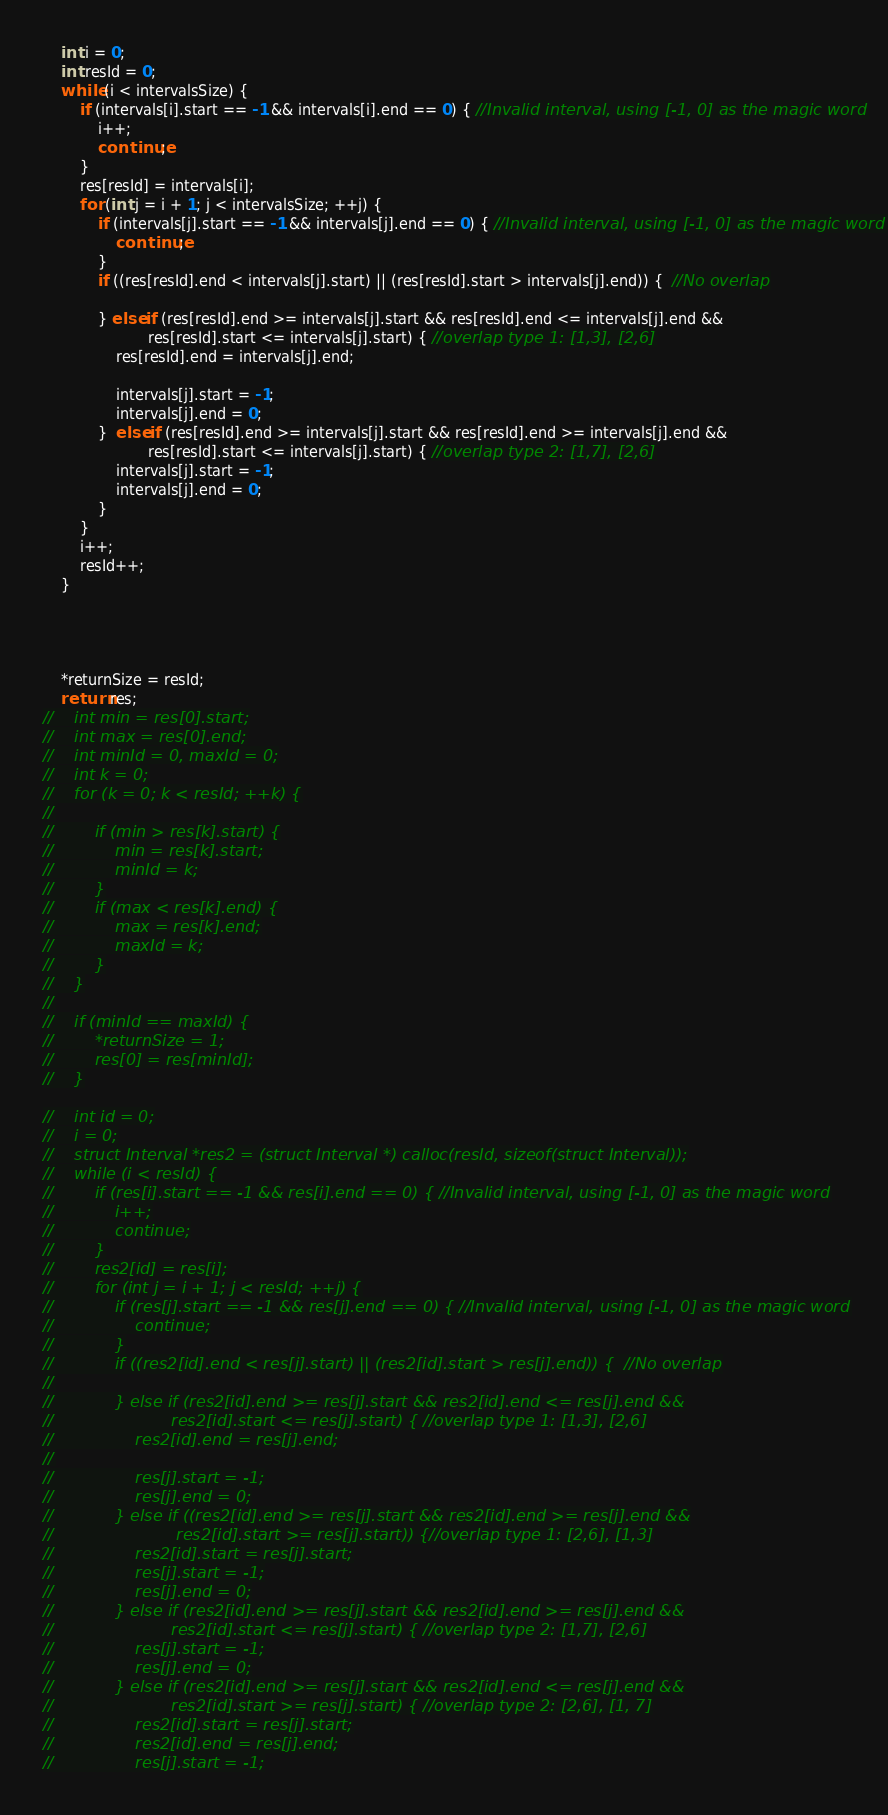<code> <loc_0><loc_0><loc_500><loc_500><_C_>
    int i = 0;
    int resId = 0;
    while (i < intervalsSize) {
        if (intervals[i].start == -1 && intervals[i].end == 0) { //Invalid interval, using [-1, 0] as the magic word
            i++;
            continue;
        }
        res[resId] = intervals[i];
        for (int j = i + 1; j < intervalsSize; ++j) {
            if (intervals[j].start == -1 && intervals[j].end == 0) { //Invalid interval, using [-1, 0] as the magic word
                continue;
            }
            if ((res[resId].end < intervals[j].start) || (res[resId].start > intervals[j].end)) {  //No overlap

            } else if (res[resId].end >= intervals[j].start && res[resId].end <= intervals[j].end &&
                       res[resId].start <= intervals[j].start) { //overlap type 1: [1,3], [2,6]
                res[resId].end = intervals[j].end;

                intervals[j].start = -1;
                intervals[j].end = 0;
            }  else if (res[resId].end >= intervals[j].start && res[resId].end >= intervals[j].end &&
                       res[resId].start <= intervals[j].start) { //overlap type 2: [1,7], [2,6]
                intervals[j].start = -1;
                intervals[j].end = 0;
            }
        }
        i++;
        resId++;
    }




    *returnSize = resId;
    return res;
//    int min = res[0].start;
//    int max = res[0].end;
//    int minId = 0, maxId = 0;
//    int k = 0;
//    for (k = 0; k < resId; ++k) {
//
//        if (min > res[k].start) {
//            min = res[k].start;
//            minId = k;
//        }
//        if (max < res[k].end) {
//            max = res[k].end;
//            maxId = k;
//        }
//    }
//
//    if (minId == maxId) {
//        *returnSize = 1;
//        res[0] = res[minId];
//    }

//    int id = 0;
//    i = 0;
//    struct Interval *res2 = (struct Interval *) calloc(resId, sizeof(struct Interval));
//    while (i < resId) {
//        if (res[i].start == -1 && res[i].end == 0) { //Invalid interval, using [-1, 0] as the magic word
//            i++;
//            continue;
//        }
//        res2[id] = res[i];
//        for (int j = i + 1; j < resId; ++j) {
//            if (res[j].start == -1 && res[j].end == 0) { //Invalid interval, using [-1, 0] as the magic word
//                continue;
//            }
//            if ((res2[id].end < res[j].start) || (res2[id].start > res[j].end)) {  //No overlap
//
//            } else if (res2[id].end >= res[j].start && res2[id].end <= res[j].end &&
//                       res2[id].start <= res[j].start) { //overlap type 1: [1,3], [2,6]
//                res2[id].end = res[j].end;
//
//                res[j].start = -1;
//                res[j].end = 0;
//            } else if ((res2[id].end >= res[j].start && res2[id].end >= res[j].end &&
//                        res2[id].start >= res[j].start)) {//overlap type 1: [2,6], [1,3]
//                res2[id].start = res[j].start;
//                res[j].start = -1;
//                res[j].end = 0;
//            } else if (res2[id].end >= res[j].start && res2[id].end >= res[j].end &&
//                       res2[id].start <= res[j].start) { //overlap type 2: [1,7], [2,6]
//                res[j].start = -1;
//                res[j].end = 0;
//            } else if (res2[id].end >= res[j].start && res2[id].end <= res[j].end &&
//                       res2[id].start >= res[j].start) { //overlap type 2: [2,6], [1, 7]
//                res2[id].start = res[j].start;
//                res2[id].end = res[j].end;
//                res[j].start = -1;</code> 